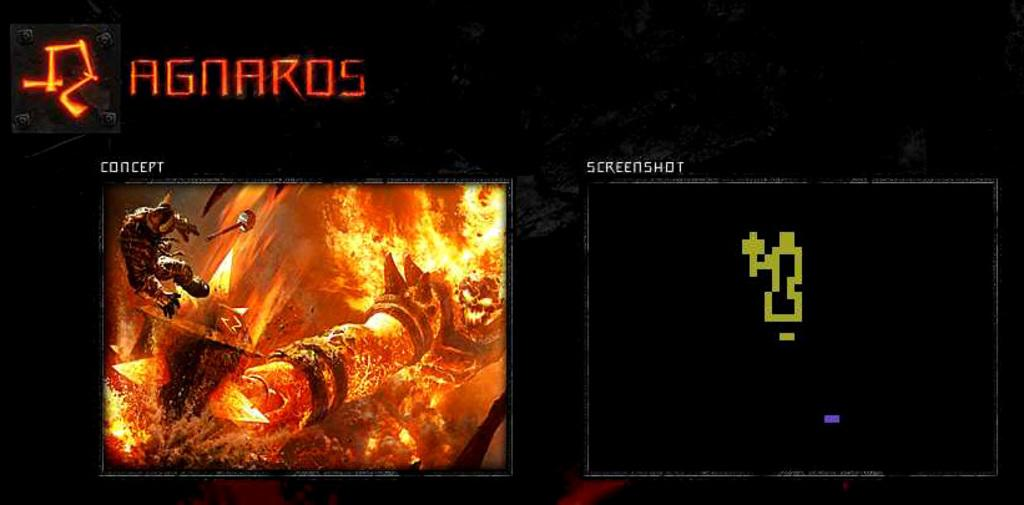<image>
Give a short and clear explanation of the subsequent image. A website screenshot showing a concept and a screenshot. 